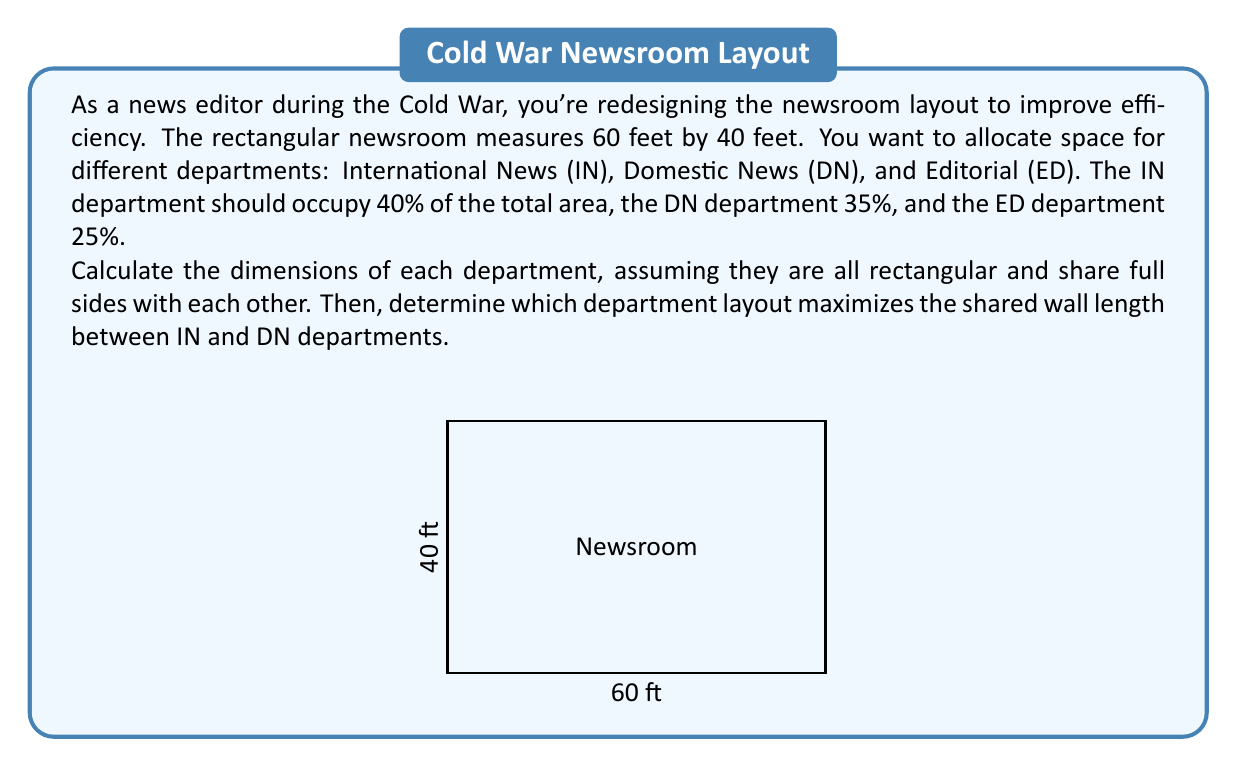Can you answer this question? Let's approach this step-by-step:

1) Calculate the total area of the newsroom:
   $A_{total} = 60 \text{ ft} \times 40 \text{ ft} = 2400 \text{ sq ft}$

2) Calculate the area for each department:
   IN: $0.40 \times 2400 = 960 \text{ sq ft}$
   DN: $0.35 \times 2400 = 840 \text{ sq ft}$
   ED: $0.25 \times 2400 = 600 \text{ sq ft}$

3) To determine the dimensions, we need to consider different layouts. Let's explore two options:

   Option 1: Vertical layout
   [asy]
   unitsize(2pt);
   draw((0,0)--(60,0)--(60,40)--(0,40)--cycle);
   draw((24,0)--(24,40));
   draw((48,0)--(48,40));
   label("IN", (12,20));
   label("DN", (36,20));
   label("ED", (54,20));
   [/asy]

   IN: $24 \text{ ft} \times 40 \text{ ft} = 960 \text{ sq ft}$
   DN: $24 \text{ ft} \times 35 \text{ ft} = 840 \text{ sq ft}$
   ED: $12 \text{ ft} \times 50 \text{ ft} = 600 \text{ sq ft}$

   Option 2: Horizontal layout
   [asy]
   unitsize(2pt);
   draw((0,0)--(60,0)--(60,40)--(0,40)--cycle);
   draw((0,24)--(60,24));
   draw((0,15)--(60,15));
   label("IN", (30,32));
   label("DN", (30,19.5));
   label("ED", (30,7.5));
   [/asy]

   IN: $60 \text{ ft} \times 16 \text{ ft} = 960 \text{ sq ft}$
   DN: $60 \text{ ft} \times 14 \text{ ft} = 840 \text{ sq ft}$
   ED: $60 \text{ ft} \times 10 \text{ ft} = 600 \text{ sq ft}$

4) To maximize the shared wall length between IN and DN:
   Vertical layout: Shared length = 40 ft
   Horizontal layout: Shared length = 60 ft

Therefore, the horizontal layout maximizes the shared wall length between IN and DN departments.
Answer: IN: 60 ft × 16 ft, DN: 60 ft × 14 ft, ED: 60 ft × 10 ft. Horizontal layout maximizes shared wall. 